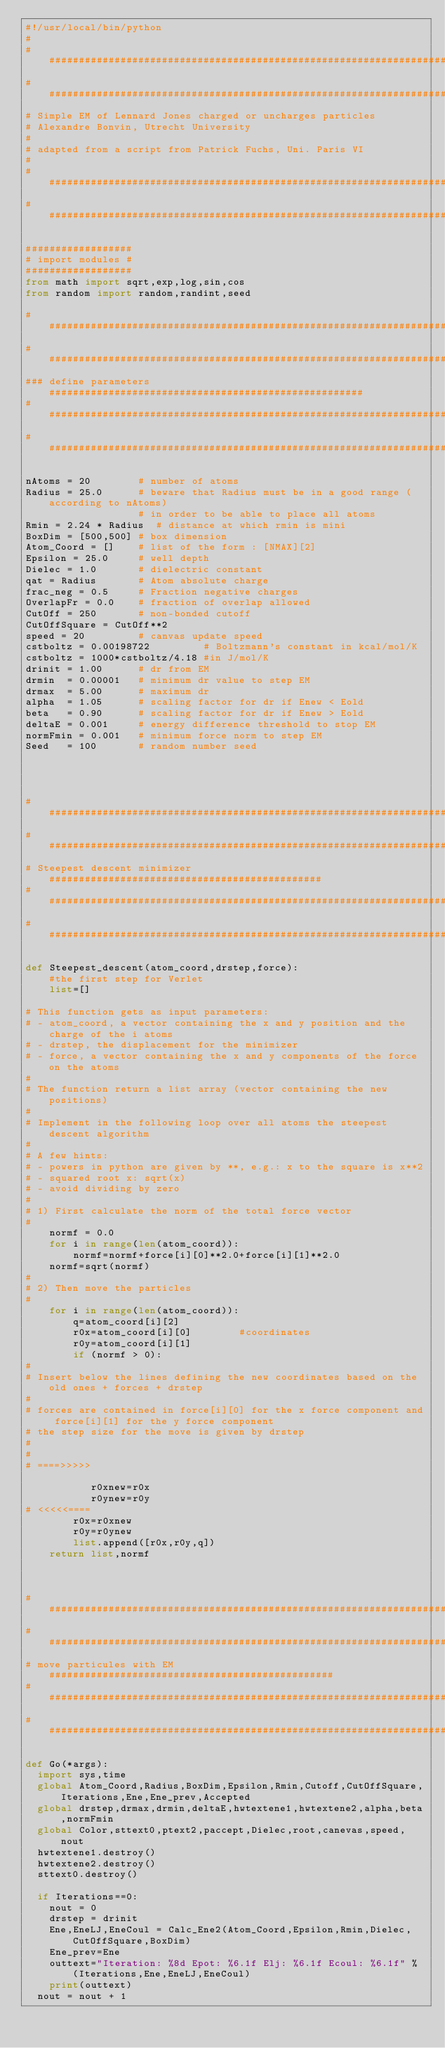Convert code to text. <code><loc_0><loc_0><loc_500><loc_500><_Python_>#!/usr/local/bin/python 
#
###########################################################################
###########################################################################
# Simple EM of Lennard Jones charged or uncharges particles
# Alexandre Bonvin, Utrecht University
#
# adapted from a script from Patrick Fuchs, Uni. Paris VI
#
###########################################################################
###########################################################################

##################
# import modules #
##################
from math import sqrt,exp,log,sin,cos
from random import random,randint,seed

###########################################################################
###########################################################################
### define parameters #####################################################
###########################################################################
###########################################################################

nAtoms = 20        # number of atoms
Radius = 25.0      # beware that Radius must be in a good range (according to nAtoms)
                   # in order to be able to place all atoms
Rmin = 2.24 * Radius  # distance at which rmin is mini
BoxDim = [500,500] # box dimension
Atom_Coord = []    # list of the form : [NMAX][2]
Epsilon = 25.0     # well depth
Dielec = 1.0       # dielectric constant
qat = Radius       # Atom absolute charge
frac_neg = 0.5     # Fraction negative charges
OverlapFr = 0.0    # fraction of overlap allowed
CutOff = 250       # non-bonded cutoff
CutOffSquare = CutOff**2
speed = 20         # canvas update speed
cstboltz = 0.00198722         # Boltzmann's constant in kcal/mol/K
cstboltz = 1000*cstboltz/4.18 #in J/mol/K
drinit = 1.00	   # dr from EM
drmin  = 0.00001   # minimum dr value to step EM
drmax  = 5.00      # maximum dr
alpha  = 1.05      # scaling factor for dr if Enew < Eold  
beta   = 0.90      # scaling factor for dr if Enew > Eold
deltaE = 0.001     # energy difference threshold to stop EM
normFmin = 0.001   # minimum force norm to step EM
Seed   = 100       # random number seed




###########################################################################
###########################################################################
# Steepest descent minimizer ##############################################
###########################################################################
###########################################################################

def Steepest_descent(atom_coord,drstep,force):
    #the first step for Verlet
    list=[]

# This function gets as input parameters:
# - atom_coord, a vector containing the x and y position and the charge of the i atoms
# - drstep, the displacement for the minimizer
# - force, a vector containing the x and y components of the force on the atoms
#
# The function return a list array (vector containing the new positions)
# 
# Implement in the following loop over all atoms the steepest descent algorithm
#
# A few hints:
# - powers in python are given by **, e.g.: x to the square is x**2
# - squared root x: sqrt(x)
# - avoid dividing by zero
#
# 1) First calculate the norm of the total force vector
#
    normf = 0.0
    for i in range(len(atom_coord)):
        normf=normf+force[i][0]**2.0+force[i][1]**2.0
    normf=sqrt(normf)
# 
# 2) Then move the particles
#
    for i in range(len(atom_coord)):
        q=atom_coord[i][2]
        r0x=atom_coord[i][0]		#coordinates
        r0y=atom_coord[i][1]
        if (normf > 0):
#
# Insert below the lines defining the new coordinates based on the old ones + forces + drstep
#
# forces are contained in force[i][0] for the x force component and force[i][1] for the y force component
# the step size for the move is given by drstep
#
# 
# ====>>>>>

           r0xnew=r0x
           r0ynew=r0y
# <<<<<====
        r0x=r0xnew
        r0y=r0ynew
        list.append([r0x,r0y,q])
    return list,normf



###########################################################################
###########################################################################
# move particules with EM  ################################################
###########################################################################
###########################################################################

def Go(*args):
  import sys,time
  global Atom_Coord,Radius,BoxDim,Epsilon,Rmin,Cutoff,CutOffSquare,Iterations,Ene,Ene_prev,Accepted
  global drstep,drmax,drmin,deltaE,hwtextene1,hwtextene2,alpha,beta,normFmin
  global Color,sttext0,ptext2,paccept,Dielec,root,canevas,speed,nout
  hwtextene1.destroy()
  hwtextene2.destroy()
  sttext0.destroy()

  if Iterations==0:
    nout = 0
    drstep = drinit
    Ene,EneLJ,EneCoul = Calc_Ene2(Atom_Coord,Epsilon,Rmin,Dielec,CutOffSquare,BoxDim)
    Ene_prev=Ene
    outtext="Iteration: %8d Epot: %6.1f Elj: %6.1f Ecoul: %6.1f" % (Iterations,Ene,EneLJ,EneCoul)
    print(outtext)
  nout = nout + 1</code> 